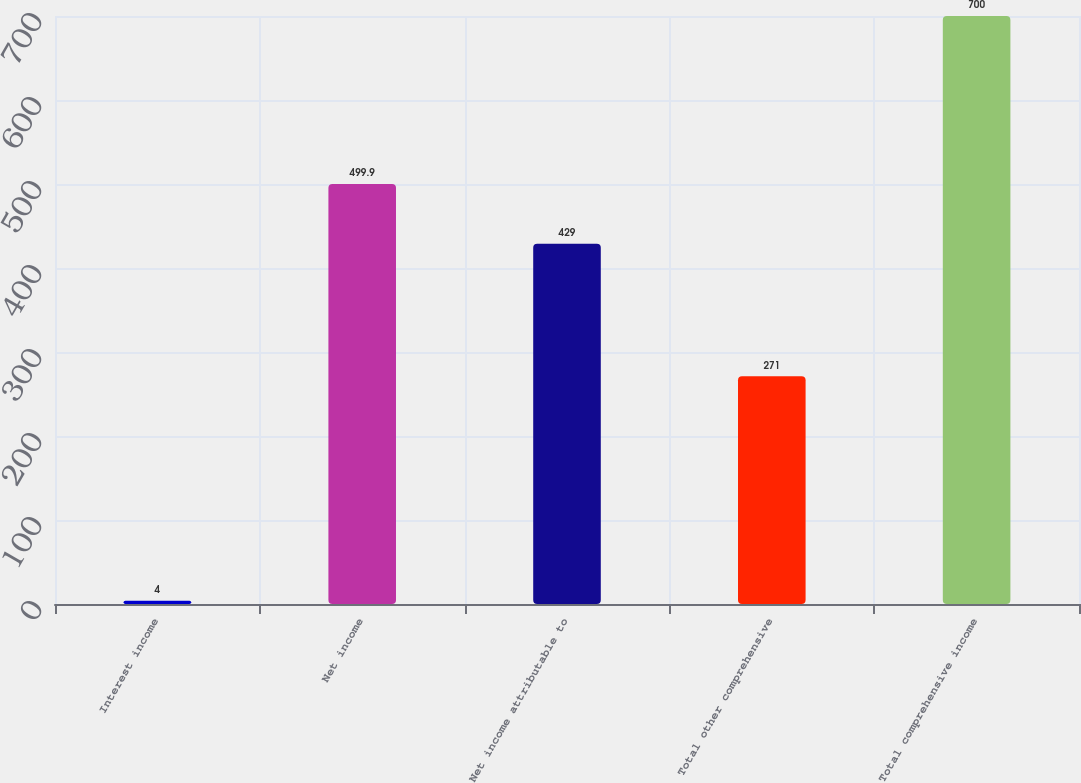<chart> <loc_0><loc_0><loc_500><loc_500><bar_chart><fcel>Interest income<fcel>Net income<fcel>Net income attributable to<fcel>Total other comprehensive<fcel>Total comprehensive income<nl><fcel>4<fcel>499.9<fcel>429<fcel>271<fcel>700<nl></chart> 